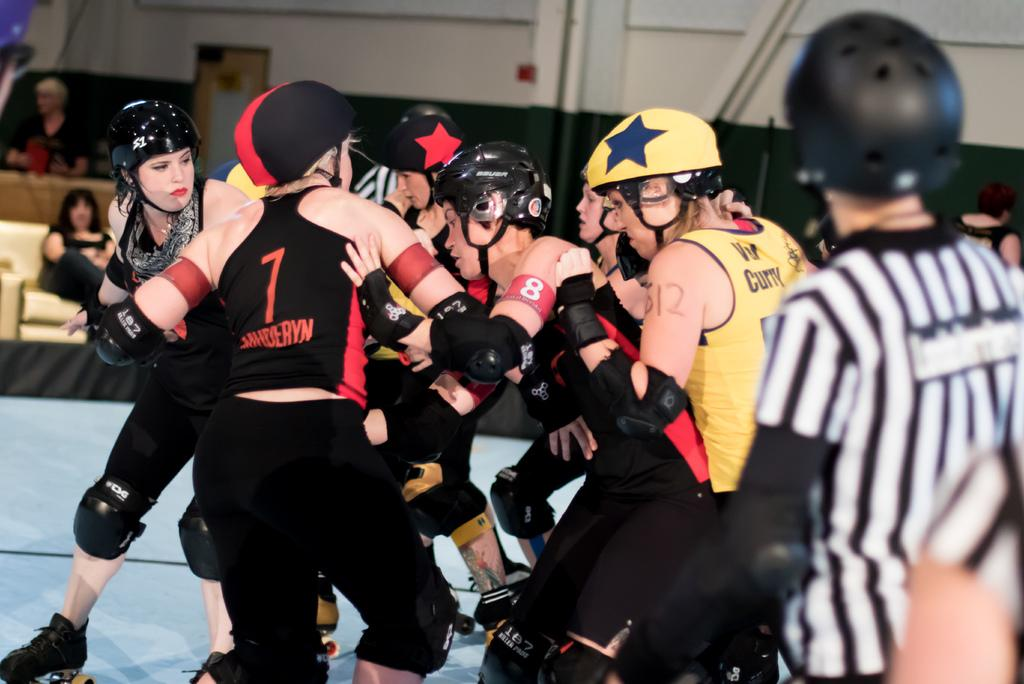What are the people in the image doing? The people in the image are standing on the ground while wearing roller skates. What protective gear are the people wearing? The people are wearing helmets. What can be seen in the background of the image? There are other people sitting on chairs in the background of the image. What type of ice can be seen melting on the roller skates in the image? There is no ice present on the roller skates in the image. What can be used to cut the helmets in the image? There are no scissors or any cutting tools present in the image. 